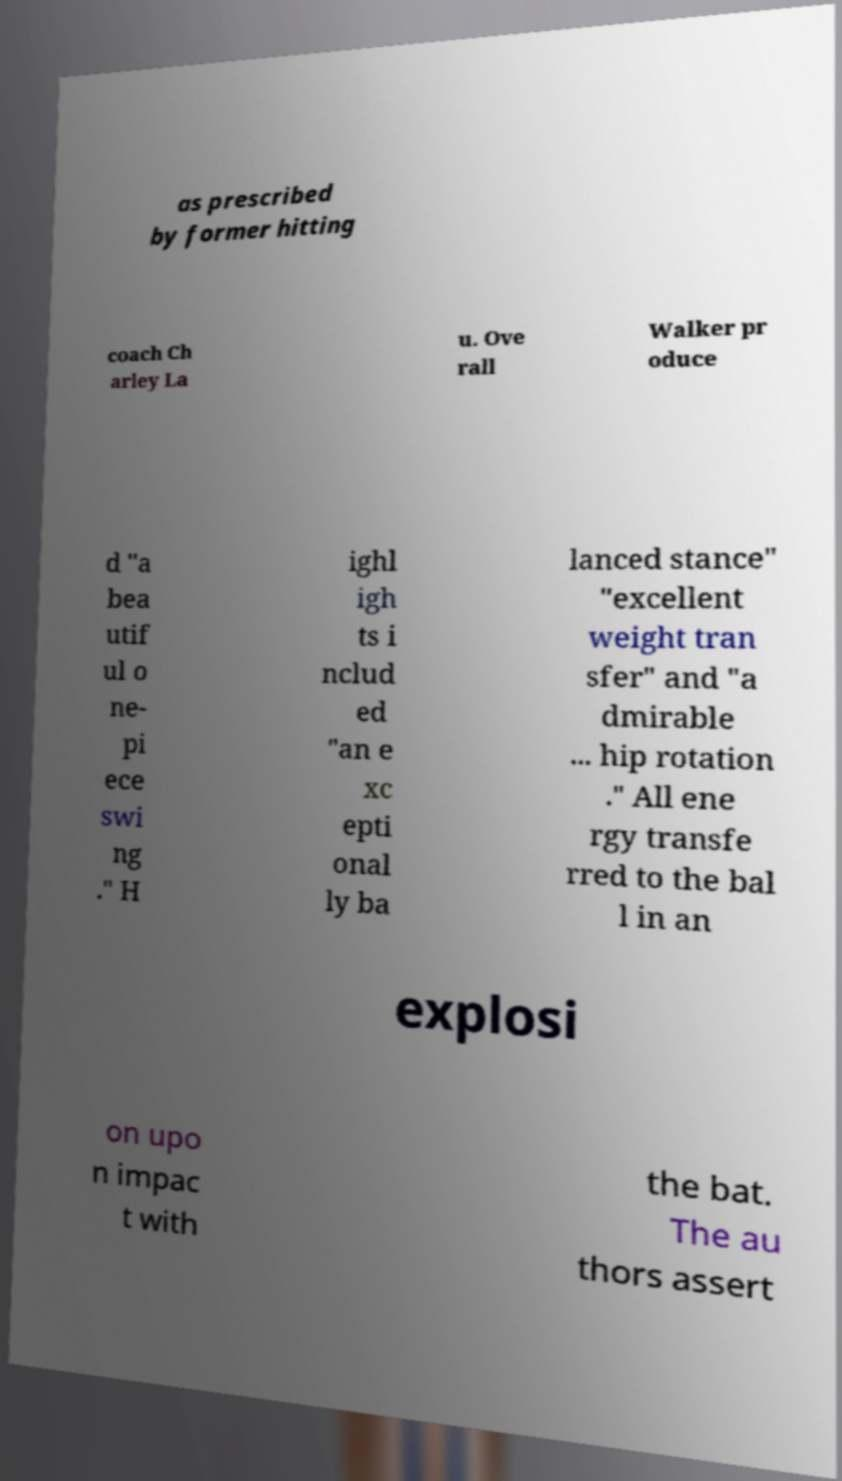What messages or text are displayed in this image? I need them in a readable, typed format. as prescribed by former hitting coach Ch arley La u. Ove rall Walker pr oduce d "a bea utif ul o ne- pi ece swi ng ." H ighl igh ts i nclud ed "an e xc epti onal ly ba lanced stance" "excellent weight tran sfer" and "a dmirable ... hip rotation ." All ene rgy transfe rred to the bal l in an explosi on upo n impac t with the bat. The au thors assert 